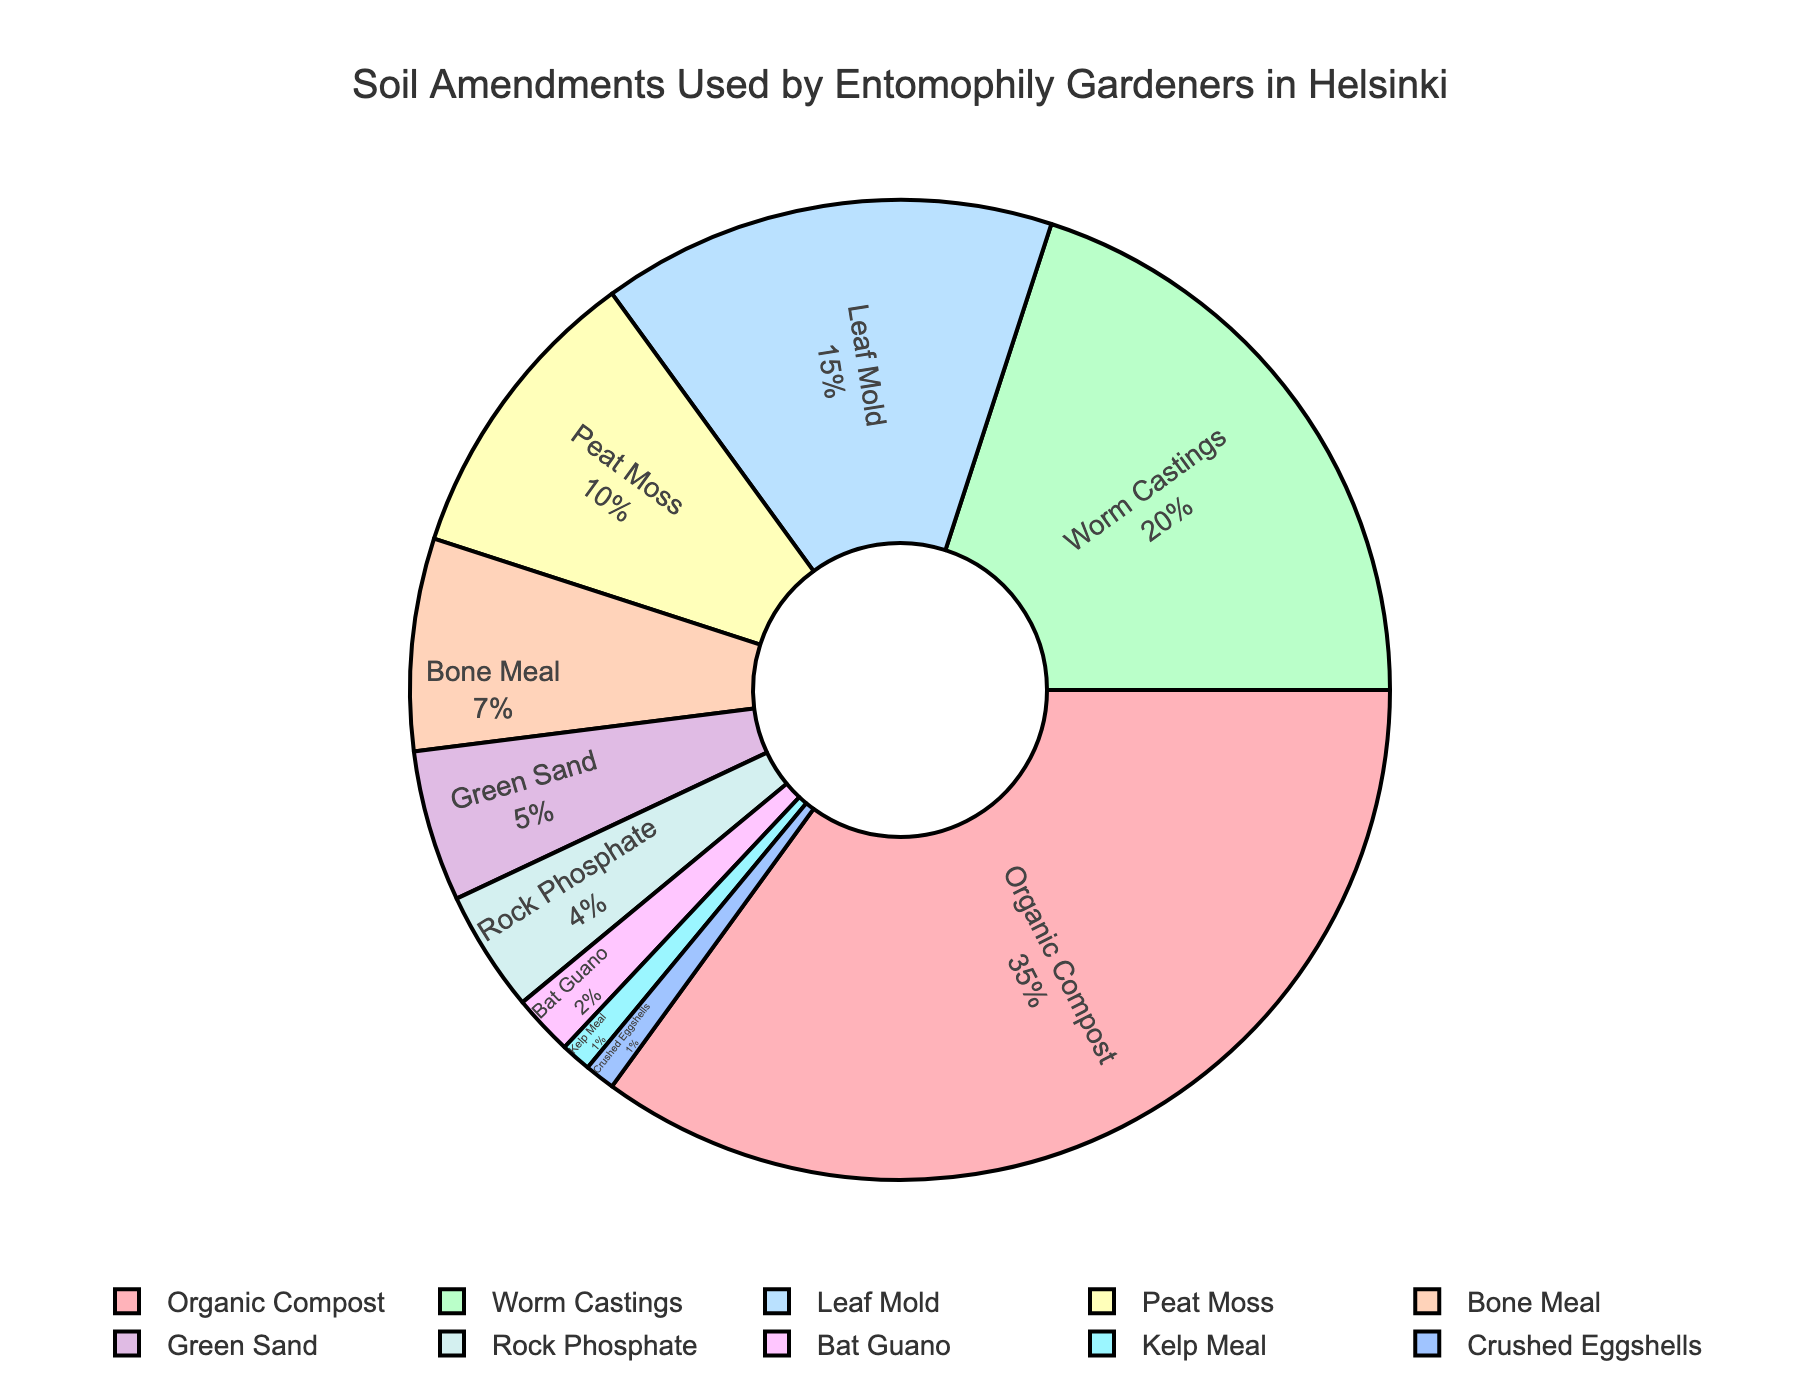what soil amendment is used the most by entomophily gardeners in Helsinki? The largest slice of the pie chart indicates the most used soil amendment is labeled "Organic Compost."
Answer: Organic Compost how much more percentage of the soil amendments is Organic Compost used compared to Bone Meal? Organic Compost is used at 35%. Bone Meal is used at 7%. The difference is 35% - 7% = 28%.
Answer: 28% which three soil amendments together account for half of the total usage? Organic Compost (35%), Worm Castings (20%), and Leaf Mold (15%) add up to 35% + 20% + 15% = 70%. The Pie chart shows that adding Leaf Mold alone exceeds the half total, so only Organic Compost and Worm Castings account for more than half (over 50%).
Answer: Organic Compost, Worm Castings, Leaf Mold what is the combined percentage of the least used three soil amendments? The least used three are Kelp Meal (1%), Crushed Eggshells (1%), and Bat Guano (2%). The sum is 1% + 1% + 2% = 4%.
Answer: 4% how does the percentage usage of Worm Castings compare to Peat Moss? The chart shows Worm Castings are used at 20%, and Peat Moss at 10%. Worm Castings are used twice as much as Peat Moss.
Answer: twice which soil amendment has a lower percentage usage: Green Sand or Rock Phosphate? The pie chart labels Green Sand has 5% and Rock Phosphate has 4%. Therefore, Rock Phosphate has a lower percentage usage.
Answer: Rock Phosphate is Leaf Mold used more than Bone Meal and Green Sand combined? The chart shows Leaf Mold at 15%. Bone Meal is 7% and Green Sand is 5%, combined 7% + 5% = 12%. Since 15% is greater than 12%, Leaf Mold is used more.
Answer: Yes which amendments use 1% of the total each? The chart indicates Kelp Meal and Crushed Eggshells each make up 1% of the total amendments used.
Answer: Kelp Meal, Crushed Eggshells how much of the total percentage do Organic Compost and Worm Castings together account for? Organic Compost is 35% and Worm Castings are 20%. Together, they account for 35% + 20% = 55% of the total.
Answer: 55% 